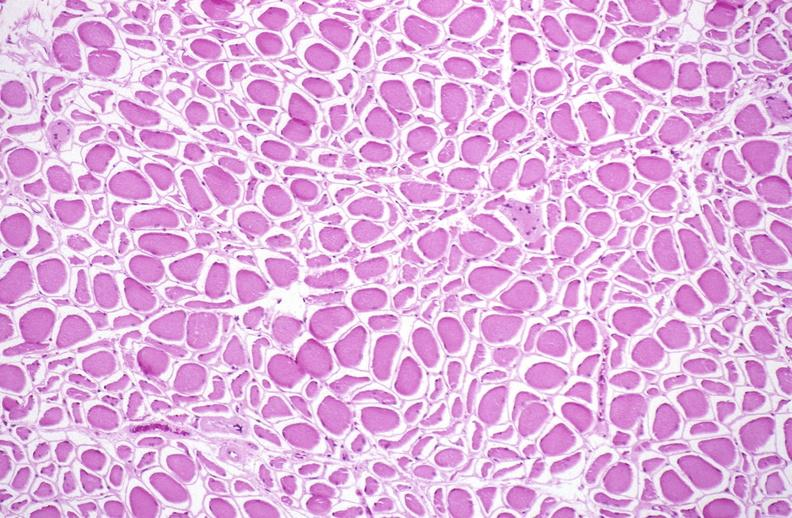s vasculature present?
Answer the question using a single word or phrase. No 